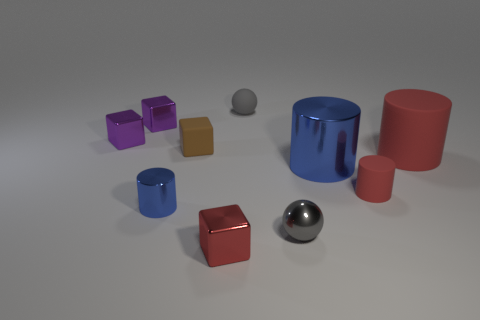Is the color of the large rubber thing the same as the small rubber cylinder?
Keep it short and to the point. Yes. There is a matte ball; is its size the same as the blue cylinder to the left of the big blue cylinder?
Provide a short and direct response. Yes. Are the blue cylinder that is to the left of the tiny red shiny cube and the red cylinder that is in front of the big red matte cylinder made of the same material?
Ensure brevity in your answer.  No. Is the number of brown blocks to the right of the tiny red shiny cube the same as the number of tiny gray spheres in front of the tiny shiny sphere?
Give a very brief answer. Yes. How many big things have the same color as the small metal cylinder?
Offer a very short reply. 1. There is a big object that is the same color as the small rubber cylinder; what material is it?
Ensure brevity in your answer.  Rubber. What number of metal objects are tiny yellow cylinders or brown objects?
Offer a terse response. 0. Do the gray object that is behind the small brown thing and the tiny gray thing in front of the tiny red matte thing have the same shape?
Your response must be concise. Yes. How many tiny cylinders are in front of the gray metal ball?
Make the answer very short. 0. Are there any brown blocks that have the same material as the large red object?
Provide a short and direct response. Yes. 